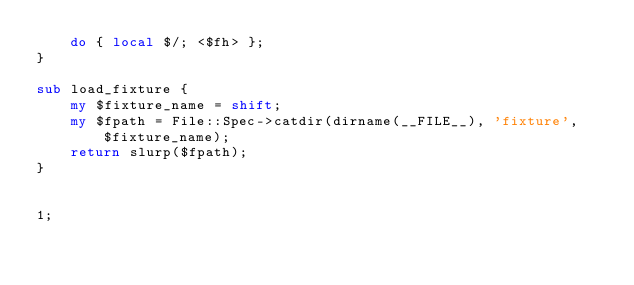<code> <loc_0><loc_0><loc_500><loc_500><_Perl_>    do { local $/; <$fh> };
}

sub load_fixture {
    my $fixture_name = shift;
    my $fpath = File::Spec->catdir(dirname(__FILE__), 'fixture', $fixture_name);
    return slurp($fpath);
}


1;
</code> 